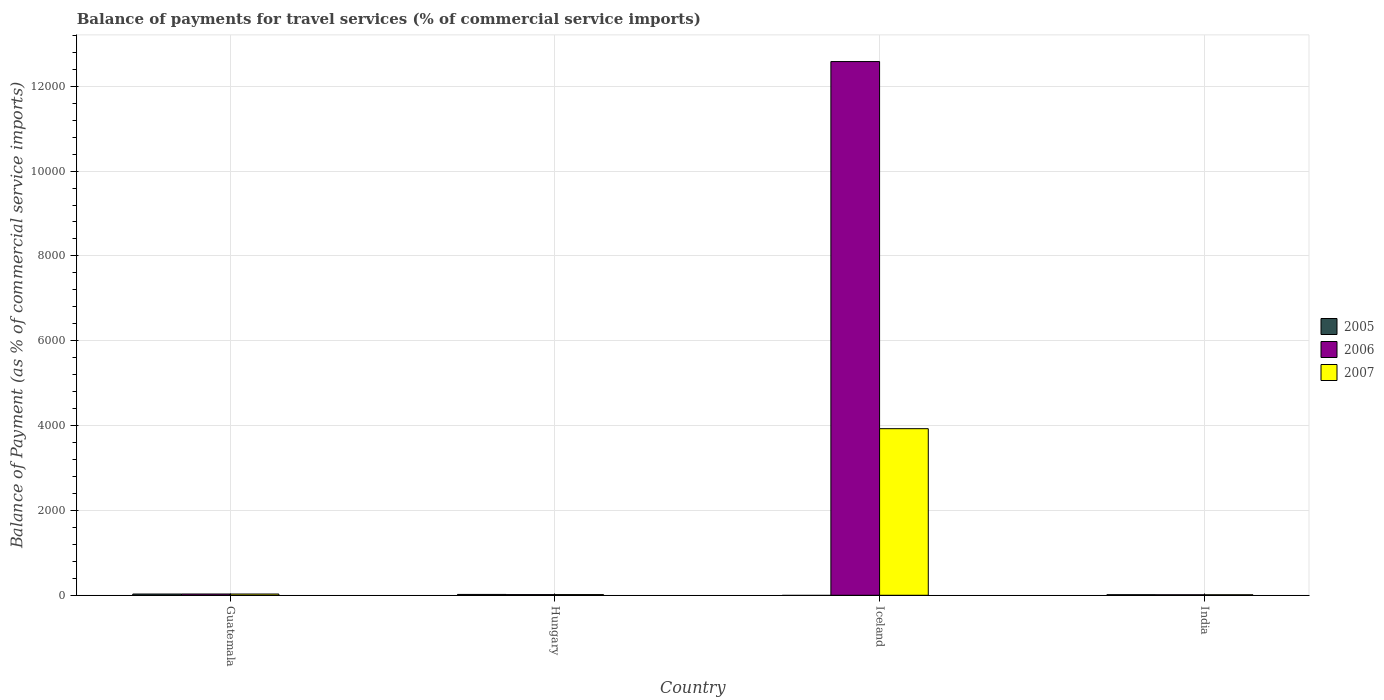How many different coloured bars are there?
Keep it short and to the point. 3. Are the number of bars per tick equal to the number of legend labels?
Provide a succinct answer. No. Are the number of bars on each tick of the X-axis equal?
Provide a short and direct response. No. How many bars are there on the 3rd tick from the right?
Provide a short and direct response. 3. What is the label of the 1st group of bars from the left?
Keep it short and to the point. Guatemala. In how many cases, is the number of bars for a given country not equal to the number of legend labels?
Offer a very short reply. 1. What is the balance of payments for travel services in 2007 in Hungary?
Ensure brevity in your answer.  16.32. Across all countries, what is the maximum balance of payments for travel services in 2005?
Offer a very short reply. 29.45. Across all countries, what is the minimum balance of payments for travel services in 2006?
Provide a succinct answer. 11.79. In which country was the balance of payments for travel services in 2007 maximum?
Offer a terse response. Iceland. What is the total balance of payments for travel services in 2006 in the graph?
Your answer should be very brief. 1.26e+04. What is the difference between the balance of payments for travel services in 2007 in Hungary and that in India?
Provide a succinct answer. 4.53. What is the difference between the balance of payments for travel services in 2007 in Iceland and the balance of payments for travel services in 2006 in India?
Make the answer very short. 3915.25. What is the average balance of payments for travel services in 2006 per country?
Provide a short and direct response. 3159.75. What is the difference between the balance of payments for travel services of/in 2006 and balance of payments for travel services of/in 2005 in Hungary?
Provide a succinct answer. -4.32. In how many countries, is the balance of payments for travel services in 2005 greater than 8400 %?
Offer a terse response. 0. What is the ratio of the balance of payments for travel services in 2006 in Guatemala to that in Iceland?
Your answer should be compact. 0. Is the difference between the balance of payments for travel services in 2006 in Guatemala and India greater than the difference between the balance of payments for travel services in 2005 in Guatemala and India?
Ensure brevity in your answer.  Yes. What is the difference between the highest and the second highest balance of payments for travel services in 2007?
Provide a short and direct response. -13.29. What is the difference between the highest and the lowest balance of payments for travel services in 2005?
Keep it short and to the point. 29.45. How many bars are there?
Offer a very short reply. 11. Are all the bars in the graph horizontal?
Make the answer very short. No. How many countries are there in the graph?
Your response must be concise. 4. Are the values on the major ticks of Y-axis written in scientific E-notation?
Your response must be concise. No. How are the legend labels stacked?
Offer a terse response. Vertical. What is the title of the graph?
Ensure brevity in your answer.  Balance of payments for travel services (% of commercial service imports). Does "1986" appear as one of the legend labels in the graph?
Your response must be concise. No. What is the label or title of the Y-axis?
Keep it short and to the point. Balance of Payment (as % of commercial service imports). What is the Balance of Payment (as % of commercial service imports) in 2005 in Guatemala?
Offer a very short reply. 29.45. What is the Balance of Payment (as % of commercial service imports) of 2006 in Guatemala?
Your answer should be compact. 30.09. What is the Balance of Payment (as % of commercial service imports) of 2007 in Guatemala?
Your answer should be very brief. 29.61. What is the Balance of Payment (as % of commercial service imports) of 2005 in Hungary?
Give a very brief answer. 20.04. What is the Balance of Payment (as % of commercial service imports) of 2006 in Hungary?
Your answer should be very brief. 15.72. What is the Balance of Payment (as % of commercial service imports) in 2007 in Hungary?
Make the answer very short. 16.32. What is the Balance of Payment (as % of commercial service imports) of 2005 in Iceland?
Give a very brief answer. 0. What is the Balance of Payment (as % of commercial service imports) in 2006 in Iceland?
Provide a succinct answer. 1.26e+04. What is the Balance of Payment (as % of commercial service imports) in 2007 in Iceland?
Offer a very short reply. 3927.05. What is the Balance of Payment (as % of commercial service imports) in 2005 in India?
Provide a short and direct response. 13.25. What is the Balance of Payment (as % of commercial service imports) in 2006 in India?
Your answer should be very brief. 11.79. What is the Balance of Payment (as % of commercial service imports) of 2007 in India?
Give a very brief answer. 11.78. Across all countries, what is the maximum Balance of Payment (as % of commercial service imports) in 2005?
Offer a very short reply. 29.45. Across all countries, what is the maximum Balance of Payment (as % of commercial service imports) in 2006?
Give a very brief answer. 1.26e+04. Across all countries, what is the maximum Balance of Payment (as % of commercial service imports) in 2007?
Your response must be concise. 3927.05. Across all countries, what is the minimum Balance of Payment (as % of commercial service imports) in 2006?
Give a very brief answer. 11.79. Across all countries, what is the minimum Balance of Payment (as % of commercial service imports) in 2007?
Provide a short and direct response. 11.78. What is the total Balance of Payment (as % of commercial service imports) of 2005 in the graph?
Give a very brief answer. 62.74. What is the total Balance of Payment (as % of commercial service imports) of 2006 in the graph?
Provide a short and direct response. 1.26e+04. What is the total Balance of Payment (as % of commercial service imports) of 2007 in the graph?
Ensure brevity in your answer.  3984.75. What is the difference between the Balance of Payment (as % of commercial service imports) in 2005 in Guatemala and that in Hungary?
Keep it short and to the point. 9.41. What is the difference between the Balance of Payment (as % of commercial service imports) in 2006 in Guatemala and that in Hungary?
Offer a terse response. 14.37. What is the difference between the Balance of Payment (as % of commercial service imports) in 2007 in Guatemala and that in Hungary?
Keep it short and to the point. 13.29. What is the difference between the Balance of Payment (as % of commercial service imports) in 2006 in Guatemala and that in Iceland?
Ensure brevity in your answer.  -1.26e+04. What is the difference between the Balance of Payment (as % of commercial service imports) in 2007 in Guatemala and that in Iceland?
Offer a terse response. -3897.44. What is the difference between the Balance of Payment (as % of commercial service imports) in 2005 in Guatemala and that in India?
Give a very brief answer. 16.2. What is the difference between the Balance of Payment (as % of commercial service imports) of 2006 in Guatemala and that in India?
Your response must be concise. 18.3. What is the difference between the Balance of Payment (as % of commercial service imports) in 2007 in Guatemala and that in India?
Give a very brief answer. 17.83. What is the difference between the Balance of Payment (as % of commercial service imports) in 2006 in Hungary and that in Iceland?
Ensure brevity in your answer.  -1.26e+04. What is the difference between the Balance of Payment (as % of commercial service imports) in 2007 in Hungary and that in Iceland?
Your answer should be compact. -3910.73. What is the difference between the Balance of Payment (as % of commercial service imports) in 2005 in Hungary and that in India?
Your response must be concise. 6.79. What is the difference between the Balance of Payment (as % of commercial service imports) of 2006 in Hungary and that in India?
Your answer should be very brief. 3.93. What is the difference between the Balance of Payment (as % of commercial service imports) of 2007 in Hungary and that in India?
Your answer should be compact. 4.53. What is the difference between the Balance of Payment (as % of commercial service imports) in 2006 in Iceland and that in India?
Give a very brief answer. 1.26e+04. What is the difference between the Balance of Payment (as % of commercial service imports) of 2007 in Iceland and that in India?
Your answer should be very brief. 3915.27. What is the difference between the Balance of Payment (as % of commercial service imports) in 2005 in Guatemala and the Balance of Payment (as % of commercial service imports) in 2006 in Hungary?
Your answer should be very brief. 13.73. What is the difference between the Balance of Payment (as % of commercial service imports) of 2005 in Guatemala and the Balance of Payment (as % of commercial service imports) of 2007 in Hungary?
Offer a very short reply. 13.13. What is the difference between the Balance of Payment (as % of commercial service imports) of 2006 in Guatemala and the Balance of Payment (as % of commercial service imports) of 2007 in Hungary?
Your answer should be very brief. 13.77. What is the difference between the Balance of Payment (as % of commercial service imports) of 2005 in Guatemala and the Balance of Payment (as % of commercial service imports) of 2006 in Iceland?
Keep it short and to the point. -1.26e+04. What is the difference between the Balance of Payment (as % of commercial service imports) in 2005 in Guatemala and the Balance of Payment (as % of commercial service imports) in 2007 in Iceland?
Offer a very short reply. -3897.6. What is the difference between the Balance of Payment (as % of commercial service imports) of 2006 in Guatemala and the Balance of Payment (as % of commercial service imports) of 2007 in Iceland?
Provide a succinct answer. -3896.96. What is the difference between the Balance of Payment (as % of commercial service imports) of 2005 in Guatemala and the Balance of Payment (as % of commercial service imports) of 2006 in India?
Your answer should be very brief. 17.66. What is the difference between the Balance of Payment (as % of commercial service imports) of 2005 in Guatemala and the Balance of Payment (as % of commercial service imports) of 2007 in India?
Give a very brief answer. 17.67. What is the difference between the Balance of Payment (as % of commercial service imports) in 2006 in Guatemala and the Balance of Payment (as % of commercial service imports) in 2007 in India?
Ensure brevity in your answer.  18.31. What is the difference between the Balance of Payment (as % of commercial service imports) of 2005 in Hungary and the Balance of Payment (as % of commercial service imports) of 2006 in Iceland?
Make the answer very short. -1.26e+04. What is the difference between the Balance of Payment (as % of commercial service imports) in 2005 in Hungary and the Balance of Payment (as % of commercial service imports) in 2007 in Iceland?
Provide a succinct answer. -3907.01. What is the difference between the Balance of Payment (as % of commercial service imports) in 2006 in Hungary and the Balance of Payment (as % of commercial service imports) in 2007 in Iceland?
Make the answer very short. -3911.32. What is the difference between the Balance of Payment (as % of commercial service imports) of 2005 in Hungary and the Balance of Payment (as % of commercial service imports) of 2006 in India?
Give a very brief answer. 8.25. What is the difference between the Balance of Payment (as % of commercial service imports) of 2005 in Hungary and the Balance of Payment (as % of commercial service imports) of 2007 in India?
Your answer should be very brief. 8.26. What is the difference between the Balance of Payment (as % of commercial service imports) of 2006 in Hungary and the Balance of Payment (as % of commercial service imports) of 2007 in India?
Provide a succinct answer. 3.94. What is the difference between the Balance of Payment (as % of commercial service imports) of 2006 in Iceland and the Balance of Payment (as % of commercial service imports) of 2007 in India?
Provide a succinct answer. 1.26e+04. What is the average Balance of Payment (as % of commercial service imports) of 2005 per country?
Provide a succinct answer. 15.69. What is the average Balance of Payment (as % of commercial service imports) in 2006 per country?
Ensure brevity in your answer.  3159.75. What is the average Balance of Payment (as % of commercial service imports) of 2007 per country?
Your answer should be very brief. 996.19. What is the difference between the Balance of Payment (as % of commercial service imports) of 2005 and Balance of Payment (as % of commercial service imports) of 2006 in Guatemala?
Provide a succinct answer. -0.64. What is the difference between the Balance of Payment (as % of commercial service imports) in 2005 and Balance of Payment (as % of commercial service imports) in 2007 in Guatemala?
Your answer should be compact. -0.16. What is the difference between the Balance of Payment (as % of commercial service imports) in 2006 and Balance of Payment (as % of commercial service imports) in 2007 in Guatemala?
Make the answer very short. 0.48. What is the difference between the Balance of Payment (as % of commercial service imports) in 2005 and Balance of Payment (as % of commercial service imports) in 2006 in Hungary?
Your response must be concise. 4.32. What is the difference between the Balance of Payment (as % of commercial service imports) of 2005 and Balance of Payment (as % of commercial service imports) of 2007 in Hungary?
Your response must be concise. 3.73. What is the difference between the Balance of Payment (as % of commercial service imports) in 2006 and Balance of Payment (as % of commercial service imports) in 2007 in Hungary?
Your answer should be very brief. -0.59. What is the difference between the Balance of Payment (as % of commercial service imports) of 2006 and Balance of Payment (as % of commercial service imports) of 2007 in Iceland?
Offer a very short reply. 8654.34. What is the difference between the Balance of Payment (as % of commercial service imports) of 2005 and Balance of Payment (as % of commercial service imports) of 2006 in India?
Keep it short and to the point. 1.45. What is the difference between the Balance of Payment (as % of commercial service imports) of 2005 and Balance of Payment (as % of commercial service imports) of 2007 in India?
Your response must be concise. 1.47. What is the difference between the Balance of Payment (as % of commercial service imports) of 2006 and Balance of Payment (as % of commercial service imports) of 2007 in India?
Your answer should be compact. 0.01. What is the ratio of the Balance of Payment (as % of commercial service imports) in 2005 in Guatemala to that in Hungary?
Ensure brevity in your answer.  1.47. What is the ratio of the Balance of Payment (as % of commercial service imports) in 2006 in Guatemala to that in Hungary?
Your answer should be very brief. 1.91. What is the ratio of the Balance of Payment (as % of commercial service imports) in 2007 in Guatemala to that in Hungary?
Provide a short and direct response. 1.81. What is the ratio of the Balance of Payment (as % of commercial service imports) of 2006 in Guatemala to that in Iceland?
Provide a succinct answer. 0. What is the ratio of the Balance of Payment (as % of commercial service imports) of 2007 in Guatemala to that in Iceland?
Make the answer very short. 0.01. What is the ratio of the Balance of Payment (as % of commercial service imports) of 2005 in Guatemala to that in India?
Offer a terse response. 2.22. What is the ratio of the Balance of Payment (as % of commercial service imports) in 2006 in Guatemala to that in India?
Your response must be concise. 2.55. What is the ratio of the Balance of Payment (as % of commercial service imports) of 2007 in Guatemala to that in India?
Make the answer very short. 2.51. What is the ratio of the Balance of Payment (as % of commercial service imports) of 2006 in Hungary to that in Iceland?
Provide a short and direct response. 0. What is the ratio of the Balance of Payment (as % of commercial service imports) of 2007 in Hungary to that in Iceland?
Make the answer very short. 0. What is the ratio of the Balance of Payment (as % of commercial service imports) in 2005 in Hungary to that in India?
Offer a very short reply. 1.51. What is the ratio of the Balance of Payment (as % of commercial service imports) in 2006 in Hungary to that in India?
Give a very brief answer. 1.33. What is the ratio of the Balance of Payment (as % of commercial service imports) in 2007 in Hungary to that in India?
Your answer should be compact. 1.38. What is the ratio of the Balance of Payment (as % of commercial service imports) of 2006 in Iceland to that in India?
Your answer should be compact. 1066.81. What is the ratio of the Balance of Payment (as % of commercial service imports) of 2007 in Iceland to that in India?
Your answer should be compact. 333.3. What is the difference between the highest and the second highest Balance of Payment (as % of commercial service imports) in 2005?
Offer a terse response. 9.41. What is the difference between the highest and the second highest Balance of Payment (as % of commercial service imports) of 2006?
Provide a succinct answer. 1.26e+04. What is the difference between the highest and the second highest Balance of Payment (as % of commercial service imports) of 2007?
Keep it short and to the point. 3897.44. What is the difference between the highest and the lowest Balance of Payment (as % of commercial service imports) in 2005?
Provide a succinct answer. 29.45. What is the difference between the highest and the lowest Balance of Payment (as % of commercial service imports) in 2006?
Make the answer very short. 1.26e+04. What is the difference between the highest and the lowest Balance of Payment (as % of commercial service imports) of 2007?
Give a very brief answer. 3915.27. 